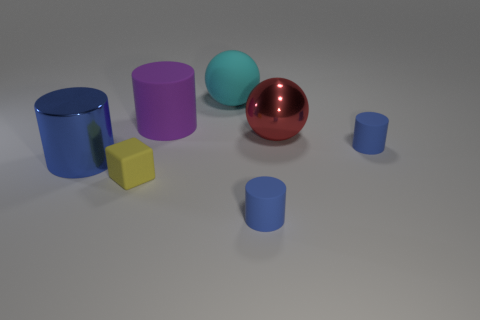What number of red metal things are there?
Your answer should be compact. 1. What number of cylinders are purple things or metal objects?
Offer a terse response. 2. There is a big blue cylinder that is in front of the large purple cylinder; what number of blue rubber cylinders are in front of it?
Provide a short and direct response. 1. Is the yellow block made of the same material as the big cyan thing?
Keep it short and to the point. Yes. Is there a blue thing made of the same material as the yellow thing?
Ensure brevity in your answer.  Yes. There is a small cylinder that is on the right side of the big thing right of the blue rubber object to the left of the red object; what color is it?
Offer a very short reply. Blue. What number of gray objects are matte balls or shiny cylinders?
Give a very brief answer. 0. How many other big objects are the same shape as the big red metal thing?
Offer a very short reply. 1. What is the shape of the blue thing that is the same size as the red sphere?
Give a very brief answer. Cylinder. Are there any red metallic spheres behind the block?
Your answer should be very brief. Yes. 